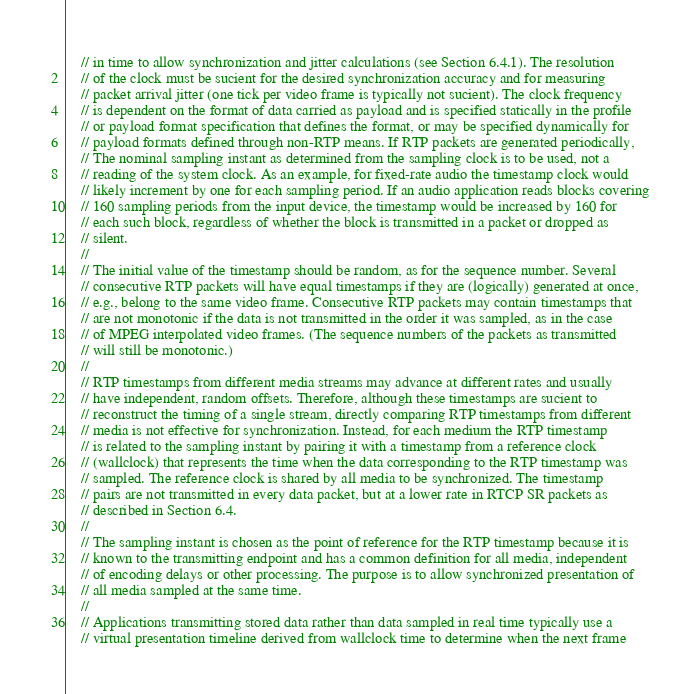<code> <loc_0><loc_0><loc_500><loc_500><_C++_>    // in time to allow synchronization and jitter calculations (see Section 6.4.1). The resolution
    // of the clock must be sucient for the desired synchronization accuracy and for measuring
    // packet arrival jitter (one tick per video frame is typically not sucient). The clock frequency
    // is dependent on the format of data carried as payload and is specified statically in the profile
    // or payload format specification that defines the format, or may be specified dynamically for
    // payload formats defined through non-RTP means. If RTP packets are generated periodically,
    // The nominal sampling instant as determined from the sampling clock is to be used, not a
    // reading of the system clock. As an example, for fixed-rate audio the timestamp clock would
    // likely increment by one for each sampling period. If an audio application reads blocks covering
    // 160 sampling periods from the input device, the timestamp would be increased by 160 for
    // each such block, regardless of whether the block is transmitted in a packet or dropped as
    // silent.
    // 
    // The initial value of the timestamp should be random, as for the sequence number. Several
    // consecutive RTP packets will have equal timestamps if they are (logically) generated at once,
    // e.g., belong to the same video frame. Consecutive RTP packets may contain timestamps that
    // are not monotonic if the data is not transmitted in the order it was sampled, as in the case
    // of MPEG interpolated video frames. (The sequence numbers of the packets as transmitted
    // will still be monotonic.)
    // 
    // RTP timestamps from different media streams may advance at different rates and usually
    // have independent, random offsets. Therefore, although these timestamps are sucient to
    // reconstruct the timing of a single stream, directly comparing RTP timestamps from different
    // media is not effective for synchronization. Instead, for each medium the RTP timestamp
    // is related to the sampling instant by pairing it with a timestamp from a reference clock
    // (wallclock) that represents the time when the data corresponding to the RTP timestamp was
    // sampled. The reference clock is shared by all media to be synchronized. The timestamp
    // pairs are not transmitted in every data packet, but at a lower rate in RTCP SR packets as
    // described in Section 6.4.
    // 
    // The sampling instant is chosen as the point of reference for the RTP timestamp because it is
    // known to the transmitting endpoint and has a common definition for all media, independent
    // of encoding delays or other processing. The purpose is to allow synchronized presentation of
    // all media sampled at the same time.
    // 
    // Applications transmitting stored data rather than data sampled in real time typically use a
    // virtual presentation timeline derived from wallclock time to determine when the next frame</code> 